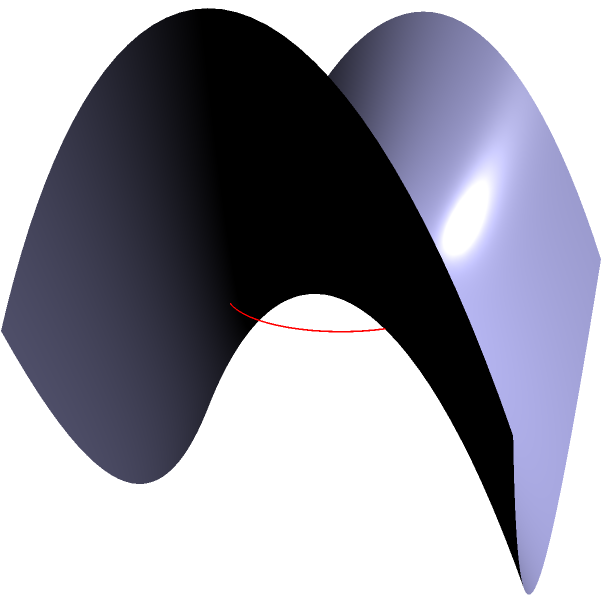On a saddle-shaped surface described by the equation $z = x^2 - y^2$, a circle with radius 1 is drawn on the $xy$-plane centered at the origin. How does the area of this circle on the saddle surface compare to its area on a flat plane? To solve this problem, let's follow these steps:

1) On a flat plane, the area of a circle with radius 1 is $A = \pi r^2 = \pi(1)^2 = \pi$.

2) On the saddle surface, we need to consider how the surface affects the area. The surface is described by $z = x^2 - y^2$.

3) To calculate the area on the curved surface, we need to use the formula for surface area in calculus:

   $A = \iint_D \sqrt{1 + (\frac{\partial z}{\partial x})^2 + (\frac{\partial z}{\partial y})^2} \, dA$

4) For our surface:
   $\frac{\partial z}{\partial x} = 2x$
   $\frac{\partial z}{\partial y} = -2y$

5) Substituting into the formula:
   $A = \iint_D \sqrt{1 + (2x)^2 + (-2y)^2} \, dA$
   $= \iint_D \sqrt{1 + 4x^2 + 4y^2} \, dA$

6) This integral is complex to solve analytically, but we can make an important observation:
   $\sqrt{1 + 4x^2 + 4y^2} \geq 1$ for all $x$ and $y$

7) This means that the area on the saddle surface will always be greater than or equal to the area on the flat plane.

Therefore, the area of the circle on the saddle-shaped surface is larger than $\pi$.
Answer: Larger than $\pi$ 